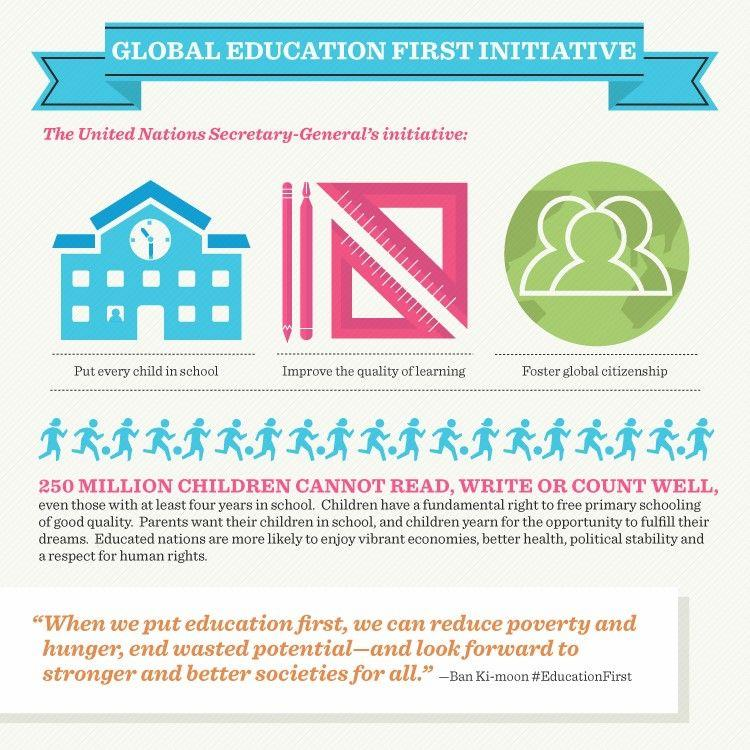Specify some key components in this picture. The color of the set-square is pink. The current United Nations Secretary-General is Ban Ki-moon. The school building is blue in color. Ban Ki-moon has taken three initiatives. As the Secretary-General of the United Nations, Ban Ki-moon launched a number of initiatives aimed at achieving three key objectives: to ensure that every child has access to quality education, to improve the quality of learning, and to foster global citizenship. These initiatives include the "Education for All" campaign, the "Global Partnership for Education," and the "United Nations Global Education First Initiative. 